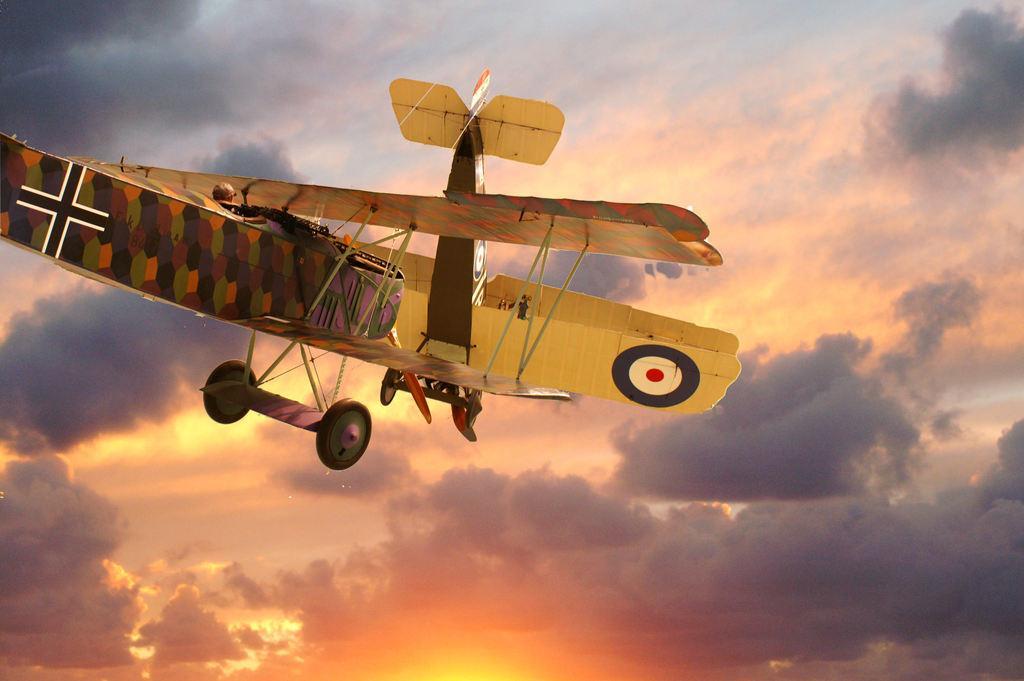Describe this image in one or two sentences. We can see airplane in the air and we can see sky is cloudy. 